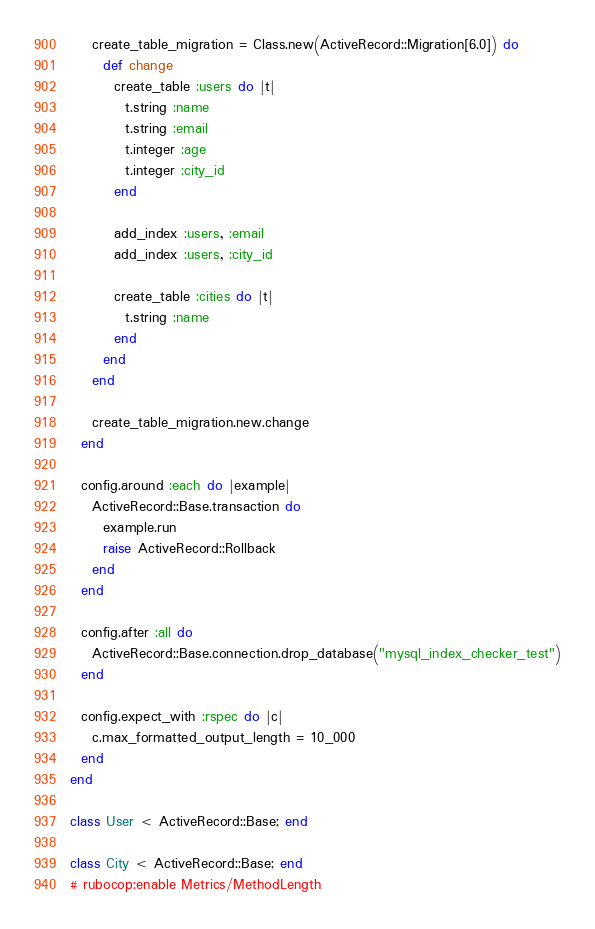Convert code to text. <code><loc_0><loc_0><loc_500><loc_500><_Ruby_>    create_table_migration = Class.new(ActiveRecord::Migration[6.0]) do
      def change
        create_table :users do |t|
          t.string :name
          t.string :email
          t.integer :age
          t.integer :city_id
        end

        add_index :users, :email
        add_index :users, :city_id

        create_table :cities do |t|
          t.string :name
        end
      end
    end

    create_table_migration.new.change
  end

  config.around :each do |example|
    ActiveRecord::Base.transaction do
      example.run
      raise ActiveRecord::Rollback
    end
  end

  config.after :all do
    ActiveRecord::Base.connection.drop_database("mysql_index_checker_test")
  end

  config.expect_with :rspec do |c|
    c.max_formatted_output_length = 10_000
  end
end

class User < ActiveRecord::Base; end

class City < ActiveRecord::Base; end
# rubocop:enable Metrics/MethodLength
</code> 